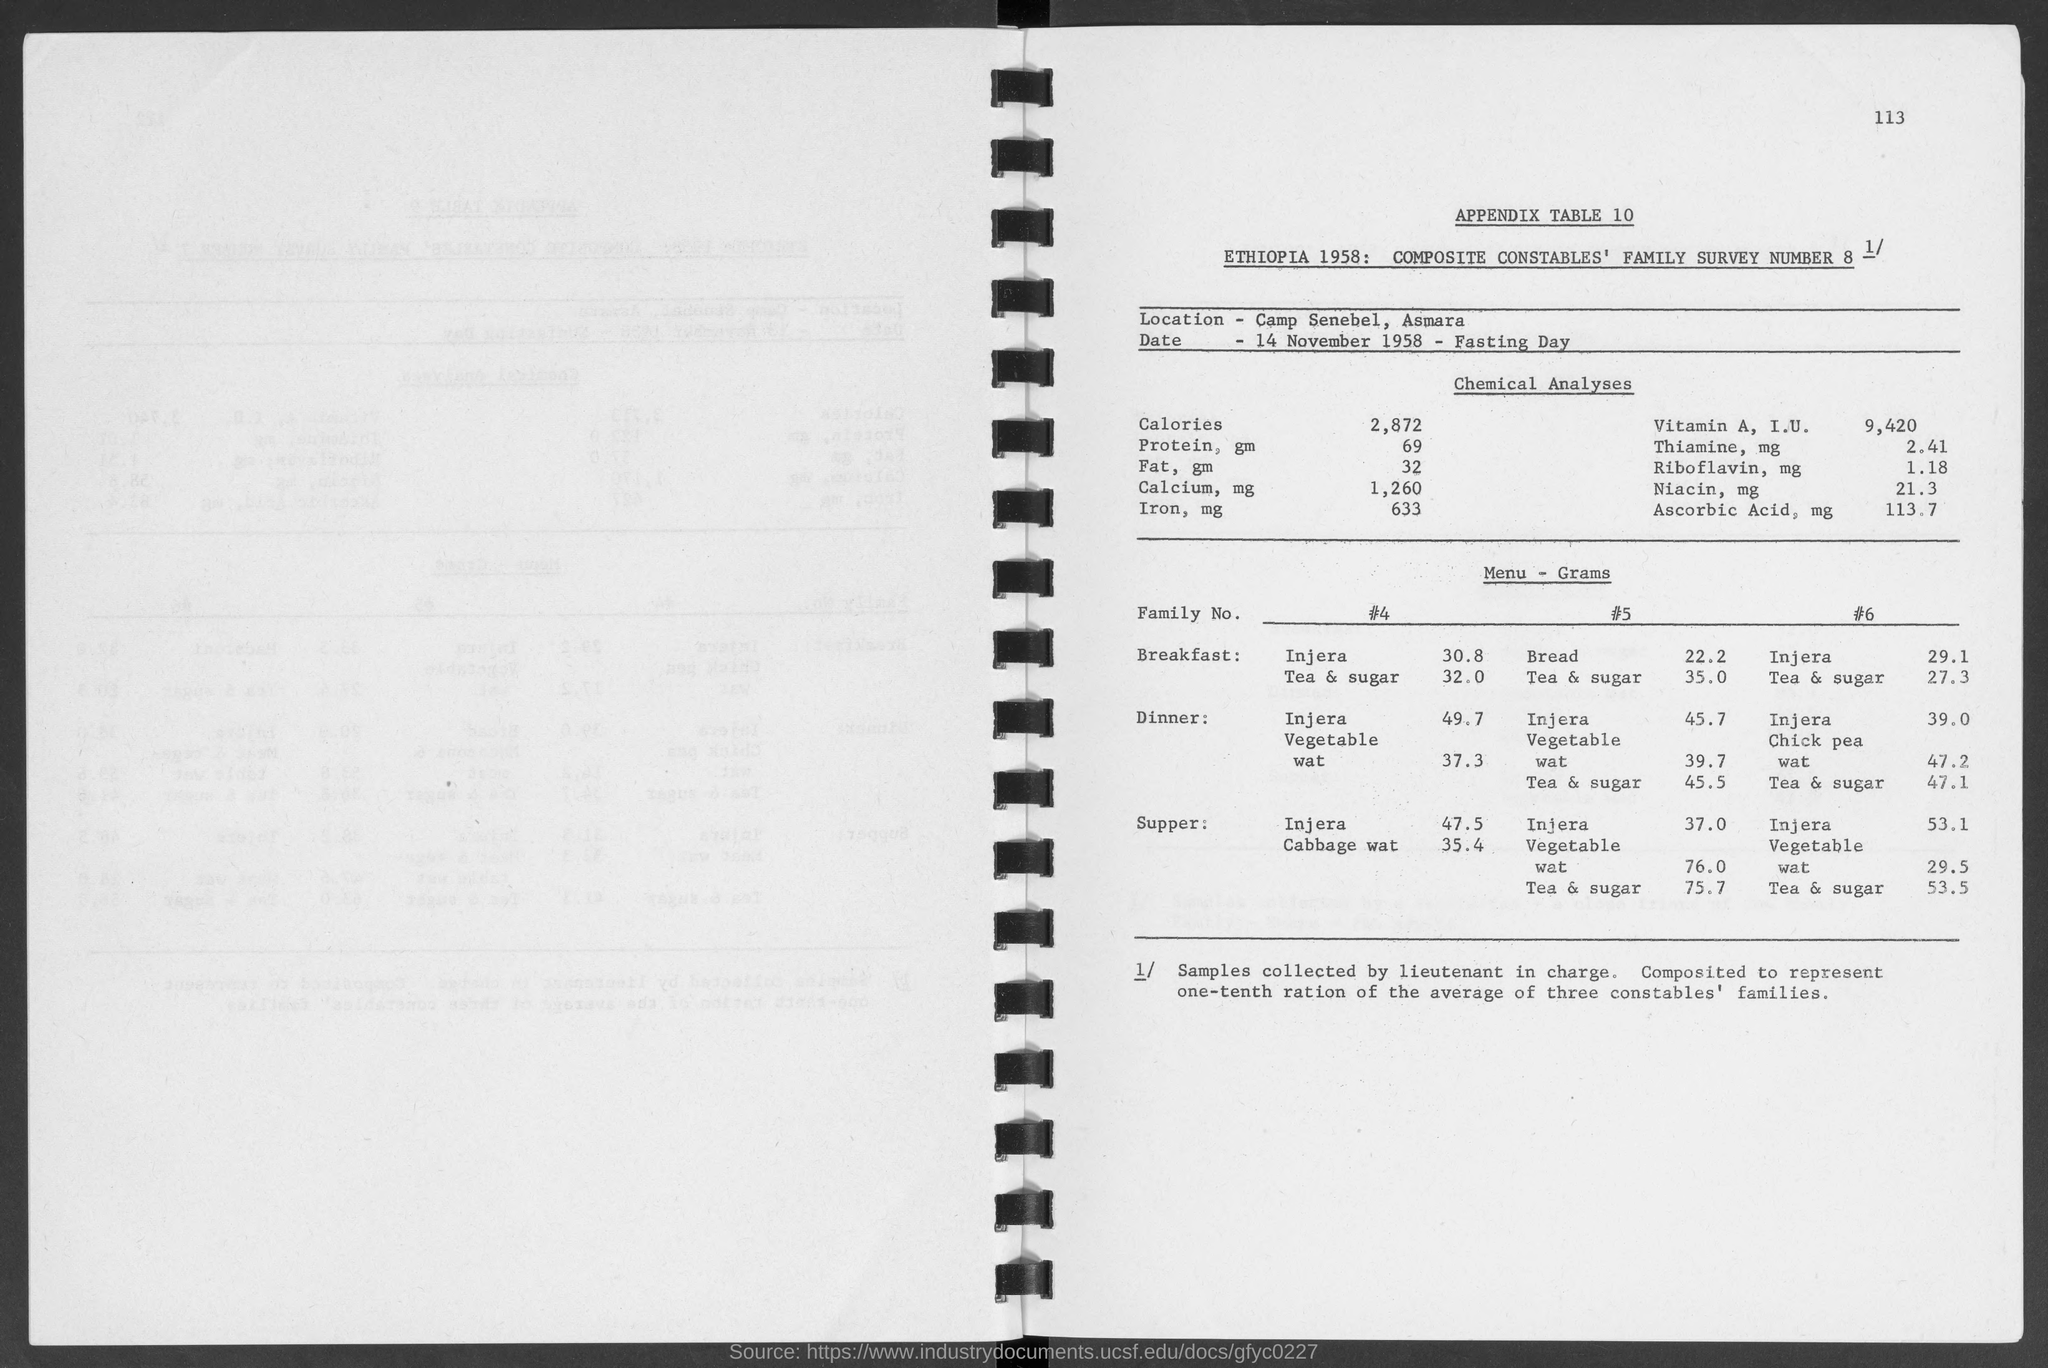What is the number at top-right corner of the page?
Give a very brief answer. 113. What is the appendix table no.?
Make the answer very short. Appendix table 10. What is the date below location ?
Provide a succinct answer. 14 November 1958. What is the amount of calories under chemical analyses ?
Provide a short and direct response. 2,872 cal. What is the amount of protein, gm under chemical analyses?
Keep it short and to the point. 69. What is the amount of fat, gm under chemical analyses?
Keep it short and to the point. 32 gm. What is the amount of calcium, mg under chemical analyses?
Your answer should be very brief. 1,260 mg. What is the amount of iron, mg under chemical analyses?
Keep it short and to the point. 633. What is the amount of thiamine, mg under chemical analyses?
Offer a very short reply. 2.41 mg. What is the amount of niacin, mg under chemical analyses?
Provide a short and direct response. 21.3 mg. 